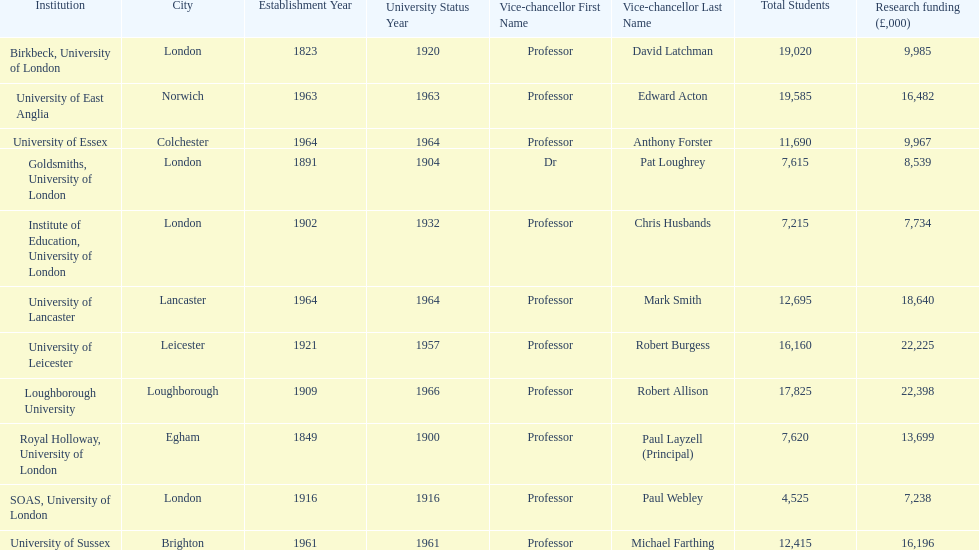Parse the full table. {'header': ['Institution', 'City', 'Establishment Year', 'University Status Year', 'Vice-chancellor First Name', 'Vice-chancellor Last Name', 'Total Students', 'Research funding (£,000)'], 'rows': [['Birkbeck, University of London', 'London', '1823', '1920', 'Professor', 'David Latchman', '19,020', '9,985'], ['University of East Anglia', 'Norwich', '1963', '1963', 'Professor', 'Edward Acton', '19,585', '16,482'], ['University of Essex', 'Colchester', '1964', '1964', 'Professor', 'Anthony Forster', '11,690', '9,967'], ['Goldsmiths, University of London', 'London', '1891', '1904', 'Dr', 'Pat Loughrey', '7,615', '8,539'], ['Institute of Education, University of London', 'London', '1902', '1932', 'Professor', 'Chris Husbands', '7,215', '7,734'], ['University of Lancaster', 'Lancaster', '1964', '1964', 'Professor', 'Mark Smith', '12,695', '18,640'], ['University of Leicester', 'Leicester', '1921', '1957', 'Professor', 'Robert Burgess', '16,160', '22,225'], ['Loughborough University', 'Loughborough', '1909', '1966', 'Professor', 'Robert Allison', '17,825', '22,398'], ['Royal Holloway, University of London', 'Egham', '1849', '1900', 'Professor', 'Paul Layzell (Principal)', '7,620', '13,699'], ['SOAS, University of London', 'London', '1916', '1916', 'Professor', 'Paul Webley', '4,525', '7,238'], ['University of Sussex', 'Brighton', '1961', '1961', 'Professor', 'Michael Farthing', '12,415', '16,196']]} How many of the institutions are located in london? 4. 